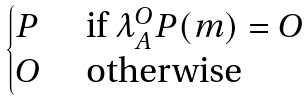Convert formula to latex. <formula><loc_0><loc_0><loc_500><loc_500>\begin{cases} P \ & \text {if $\lambda_{A}^{O}P (m) = O$} \\ O \ & \text {otherwise} \end{cases}</formula> 